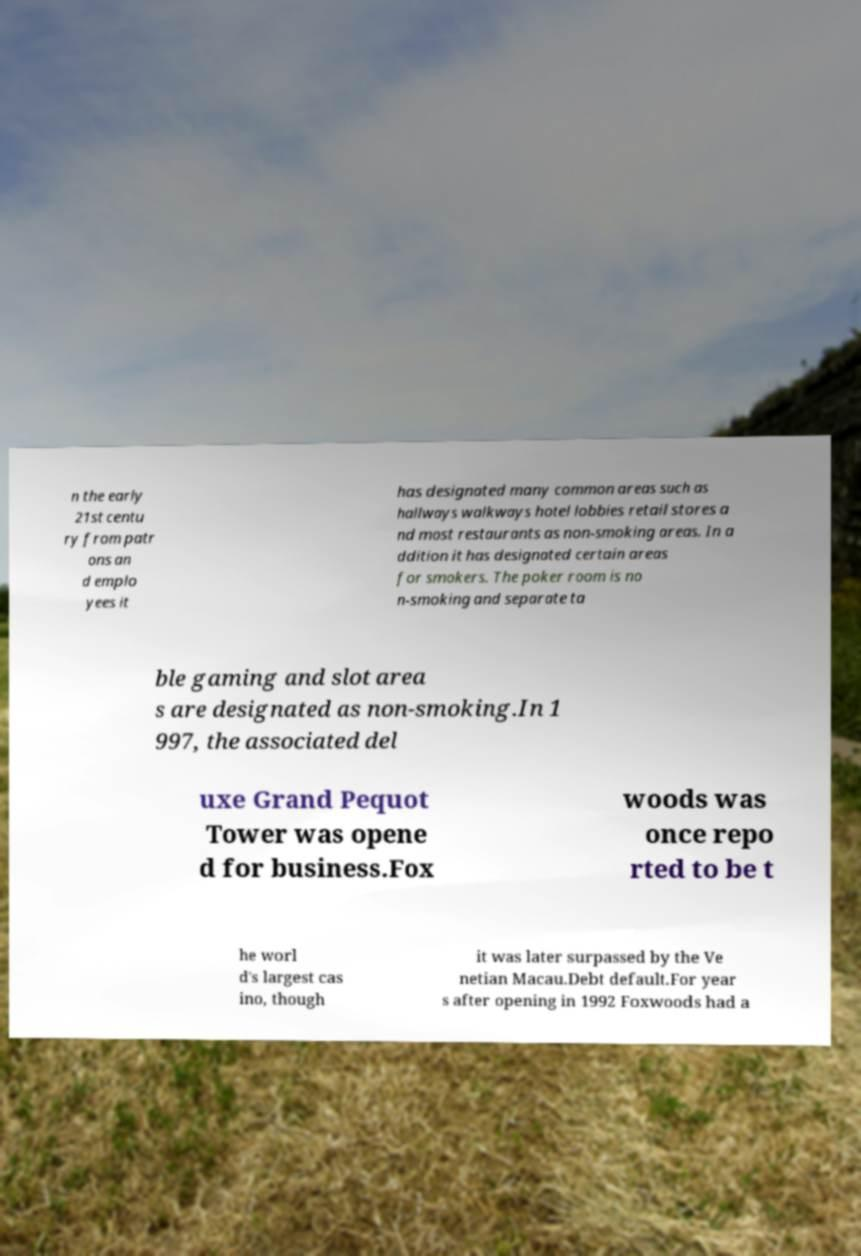Could you assist in decoding the text presented in this image and type it out clearly? n the early 21st centu ry from patr ons an d emplo yees it has designated many common areas such as hallways walkways hotel lobbies retail stores a nd most restaurants as non-smoking areas. In a ddition it has designated certain areas for smokers. The poker room is no n-smoking and separate ta ble gaming and slot area s are designated as non-smoking.In 1 997, the associated del uxe Grand Pequot Tower was opene d for business.Fox woods was once repo rted to be t he worl d's largest cas ino, though it was later surpassed by the Ve netian Macau.Debt default.For year s after opening in 1992 Foxwoods had a 